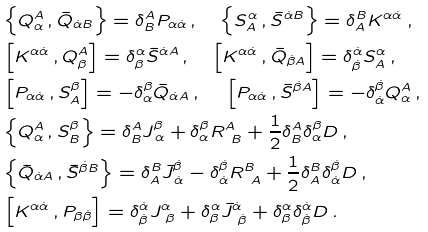Convert formula to latex. <formula><loc_0><loc_0><loc_500><loc_500>& \Big { \{ } Q ^ { A } _ { \alpha } \, , \bar { Q } _ { \dot { \alpha } B } \Big { \} } = \delta ^ { A } _ { B } P _ { \alpha \dot { \alpha } } \, , \quad \Big { \{ } S ^ { \alpha } _ { A } \, , \bar { S } ^ { \dot { \alpha } B } \Big { \} } = \delta ^ { B } _ { A } K ^ { \alpha \dot { \alpha } } \, , \\ & \Big { [ } K ^ { \alpha \dot { \alpha } } \, , Q ^ { A } _ { \beta } \Big { ] } = \delta ^ { \alpha } _ { \beta } \bar { S } ^ { \dot { \alpha } A } \, , \quad \Big { [ } K ^ { \alpha \dot { \alpha } } \, , \bar { Q } _ { \dot { \beta } A } \Big { ] } = \delta ^ { \dot { \alpha } } _ { \dot { \beta } } S ^ { \alpha } _ { A } \, , \\ & \Big { [ } P _ { \alpha \dot { \alpha } } \, , S ^ { \beta } _ { A } \Big { ] } = - \delta ^ { \beta } _ { \alpha } \bar { Q } _ { \dot { \alpha } A } \, , \quad \, \Big { [ } P _ { \alpha \dot { \alpha } } \, , \bar { S } ^ { \dot { \beta } A } \Big { ] } = - \delta ^ { \dot { \beta } } _ { \dot { \alpha } } Q _ { \alpha } ^ { A } \, , \\ & \Big { \{ } Q ^ { A } _ { \alpha } \, , S ^ { \beta } _ { B } \Big { \} } = \delta ^ { A } _ { B } J ^ { \beta } _ { \, \alpha } + \delta ^ { \beta } _ { \alpha } R ^ { A } _ { \ B } + \frac { 1 } { 2 } \delta ^ { A } _ { B } \delta ^ { \beta } _ { \alpha } D \, , \\ & \Big { \{ } \bar { Q } _ { \dot { \alpha } A } \, , \bar { S } ^ { \dot { \beta } B } \Big { \} } = \delta ^ { B } _ { A } \bar { J } ^ { \dot { \beta } } _ { \, \dot { \alpha } } - \delta ^ { \dot { \beta } } _ { \dot { \alpha } } R ^ { B } _ { \ A } + \frac { 1 } { 2 } \delta ^ { B } _ { A } \delta ^ { \dot { \beta } } _ { \dot { \alpha } } D \, , \\ & \Big { [ } K ^ { \alpha \dot { \alpha } } \, , P _ { \beta \dot { \beta } } \Big { ] } = \delta ^ { \dot { \alpha } } _ { \dot { \beta } } J ^ { \alpha } _ { \ \beta } + \delta ^ { \alpha } _ { \beta } \bar { J } ^ { \dot { \alpha } } _ { \ \dot { \beta } } + \delta ^ { \alpha } _ { \beta } \delta ^ { \dot { \alpha } } _ { \dot { \beta } } D \, .</formula> 